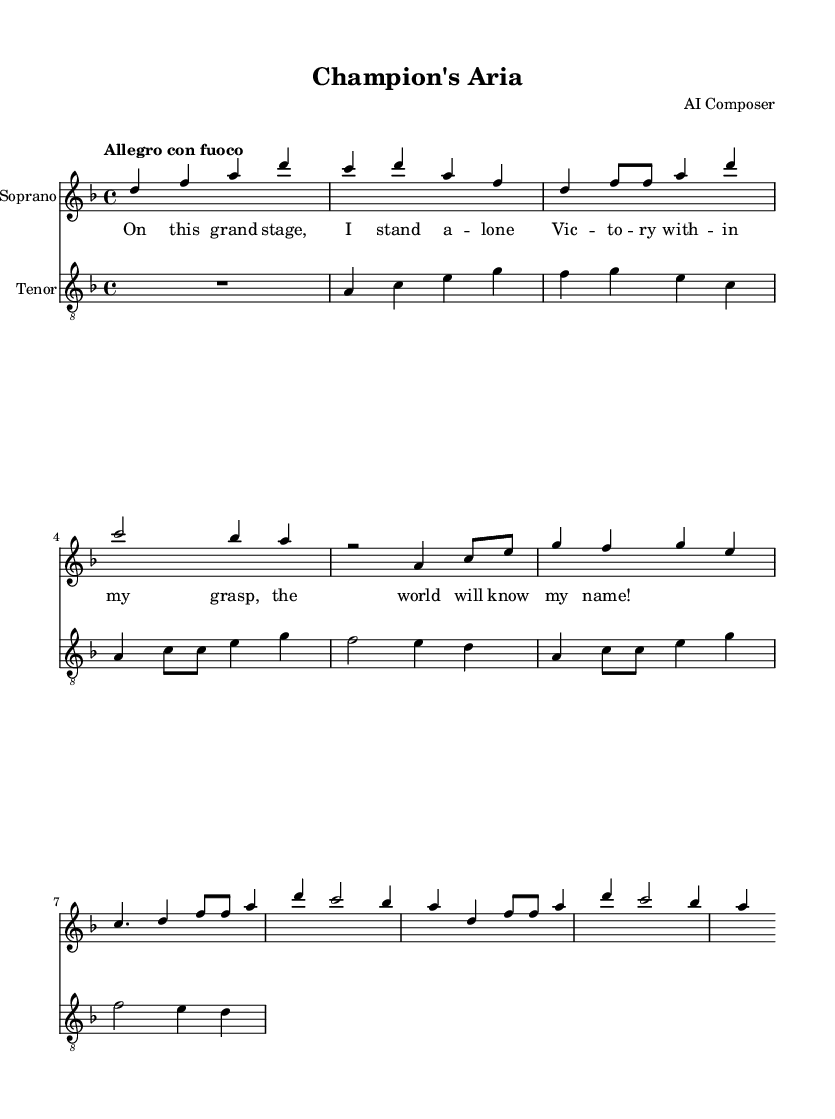What is the key signature of this music? The key signature is indicated at the beginning of the piece. In this case, it's two flats shown at the start, indicating it's in D minor.
Answer: D minor What is the time signature of this music? The time signature is displayed at the beginning of the score. Here, it shows a four over four notation, which means there are four beats in each measure.
Answer: 4/4 What is the tempo marking for this music? The tempo is suggested at the beginning as “Allegro con fuoco,” which indicates a fast pace with fire or passion.
Answer: Allegro con fuoco How many measures are in the soprano part? By counting the segments separated by vertical lines (bar lines) in the soprano part, we find that there are six measures.
Answer: Six What are the first two words sung by the soprano? The initial words in the lyrics indicate the opening phrase sung by the soprano, which is "On this grand."
Answer: On this grand How do the themes of the soprano and tenor reflect competition? The soprano's theme expresses triumph and individuality, while the tenor's theme introduces a rival feeling, creating a sense of conflict and competition between the two. This represents the dramatic elements of opera.
Answer: Competition and rivalry 